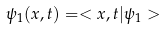<formula> <loc_0><loc_0><loc_500><loc_500>\psi _ { 1 } ( x , t ) = < x , t | \psi _ { 1 } ></formula> 